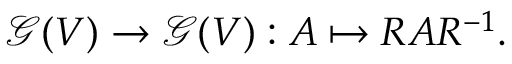<formula> <loc_0><loc_0><loc_500><loc_500>{ \mathcal { G } } ( V ) \to { \mathcal { G } } ( V ) \colon A \mapsto R A R ^ { - 1 } .</formula> 